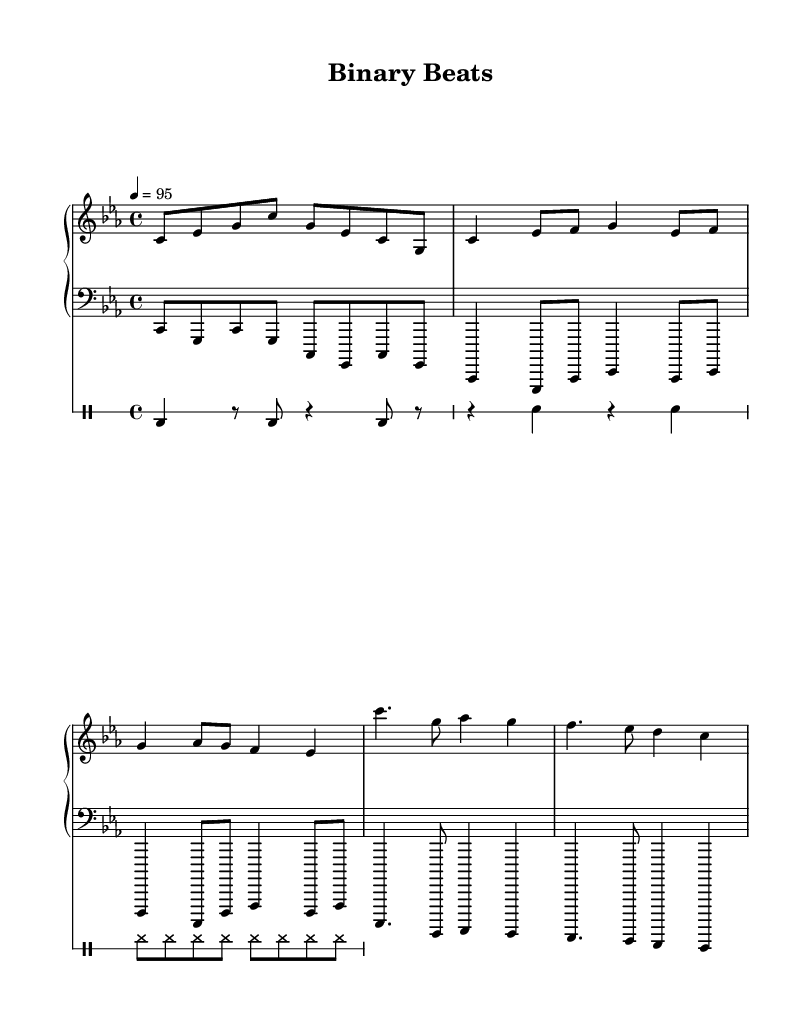What is the key signature of this music? The key signature is C minor, which includes three flats (B♭, E♭, and A♭). It is identifiable by looking at the clef and the key signature at the beginning of the staff.
Answer: C minor What is the time signature of this music? The time signature is 4/4, indicated at the beginning of the piece, meaning there are four beats per measure and the quarter note gets one beat.
Answer: 4/4 What is the tempo marking for this piece? The tempo marking is 95 beats per minute, which is expressed in the code as "4 = 95," indicating the speed at which to perform the piece.
Answer: 95 How many measures are in the chorus section? There are two measures in the chorus section, which can be determined by counting the bars in the chorus segment that starts with the notes "c''4. g8..."
Answer: 2 What type of instruments are included in this composition? The instruments are a piano (with both left and right-hand parts) and a drum machine, as indicated by the parts for each instrument in the score.
Answer: Piano and drum machine What rhythmic pattern is primarily used in the drum section? The drum section primarily features a combination of bass drum hits and snare hits, indicating a typical hip-hop rhythm pattern, following a kick-snare approach.
Answer: Kick-snare Which note is the first note of the verse? The first note of the verse is C, which can be found in the lead synth section where the verse begins with "c4 es8 f g4 es8 f."
Answer: C 